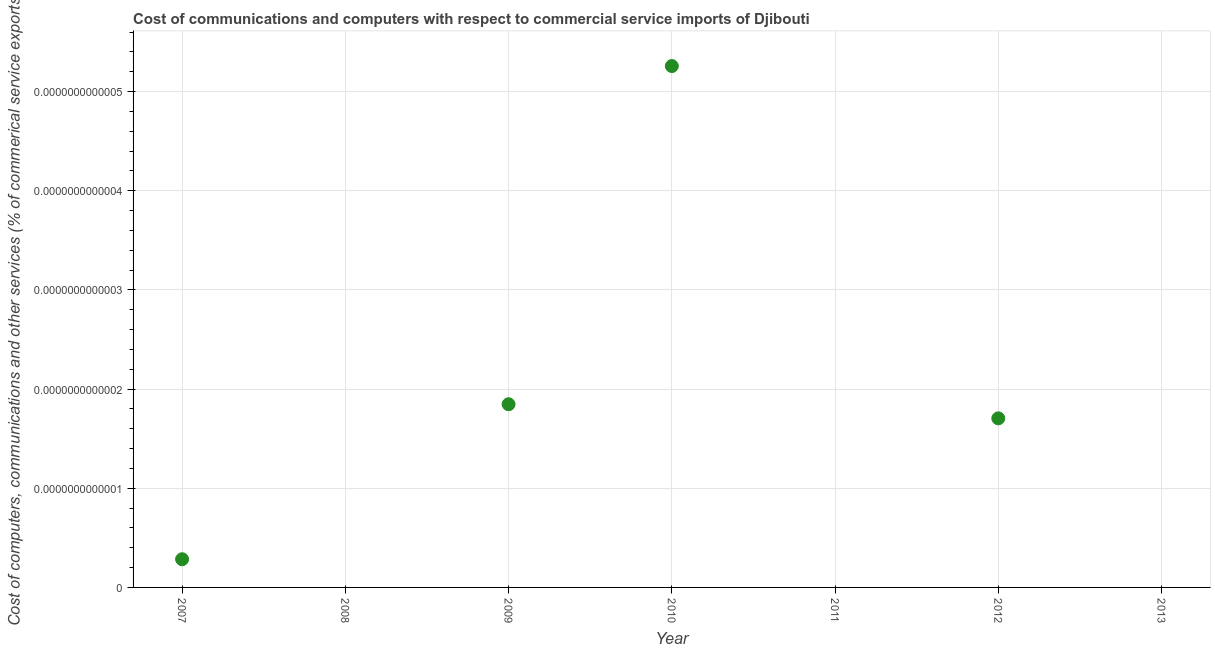Across all years, what is the maximum cost of communications?
Your response must be concise. 5.258016244624737e-13. In which year was the cost of communications maximum?
Ensure brevity in your answer.  2010. What is the sum of the  computer and other services?
Keep it short and to the point. 9.094947017729278e-13. What is the difference between the cost of communications in 2010 and 2012?
Offer a terse response. 3.5527136788004974e-13. What is the average cost of communications per year?
Provide a short and direct response. 1.299278145389897e-13. What is the median  computer and other services?
Give a very brief answer. 2.8421709430404e-14. In how many years, is the cost of communications greater than 2.2e-13 %?
Your answer should be very brief. 1. What is the ratio of the  computer and other services in 2007 to that in 2012?
Make the answer very short. 0.17. Is the  computer and other services in 2007 less than that in 2012?
Your answer should be compact. Yes. Is the difference between the cost of communications in 2009 and 2012 greater than the difference between any two years?
Make the answer very short. No. What is the difference between the highest and the second highest  computer and other services?
Give a very brief answer. 3.4106051316484774e-13. What is the difference between the highest and the lowest  computer and other services?
Your response must be concise. 5.258016244624737e-13. How many years are there in the graph?
Your answer should be very brief. 7. What is the difference between two consecutive major ticks on the Y-axis?
Offer a terse response. 1e-13. Are the values on the major ticks of Y-axis written in scientific E-notation?
Offer a terse response. No. What is the title of the graph?
Your answer should be very brief. Cost of communications and computers with respect to commercial service imports of Djibouti. What is the label or title of the Y-axis?
Your answer should be compact. Cost of computers, communications and other services (% of commerical service exports). What is the Cost of computers, communications and other services (% of commerical service exports) in 2007?
Your response must be concise. 2.8421709430404e-14. What is the Cost of computers, communications and other services (% of commerical service exports) in 2008?
Give a very brief answer. 0. What is the Cost of computers, communications and other services (% of commerical service exports) in 2009?
Your answer should be compact. 1.84741111297626e-13. What is the Cost of computers, communications and other services (% of commerical service exports) in 2010?
Provide a short and direct response. 5.258016244624737e-13. What is the Cost of computers, communications and other services (% of commerical service exports) in 2011?
Ensure brevity in your answer.  0. What is the Cost of computers, communications and other services (% of commerical service exports) in 2012?
Provide a succinct answer. 1.70530256582424e-13. What is the difference between the Cost of computers, communications and other services (% of commerical service exports) in 2007 and 2012?
Provide a succinct answer. -0. What is the difference between the Cost of computers, communications and other services (% of commerical service exports) in 2009 and 2012?
Offer a terse response. 0. What is the difference between the Cost of computers, communications and other services (% of commerical service exports) in 2010 and 2012?
Give a very brief answer. 0. What is the ratio of the Cost of computers, communications and other services (% of commerical service exports) in 2007 to that in 2009?
Provide a short and direct response. 0.15. What is the ratio of the Cost of computers, communications and other services (% of commerical service exports) in 2007 to that in 2010?
Make the answer very short. 0.05. What is the ratio of the Cost of computers, communications and other services (% of commerical service exports) in 2007 to that in 2012?
Your answer should be compact. 0.17. What is the ratio of the Cost of computers, communications and other services (% of commerical service exports) in 2009 to that in 2010?
Your answer should be compact. 0.35. What is the ratio of the Cost of computers, communications and other services (% of commerical service exports) in 2009 to that in 2012?
Keep it short and to the point. 1.08. What is the ratio of the Cost of computers, communications and other services (% of commerical service exports) in 2010 to that in 2012?
Give a very brief answer. 3.08. 